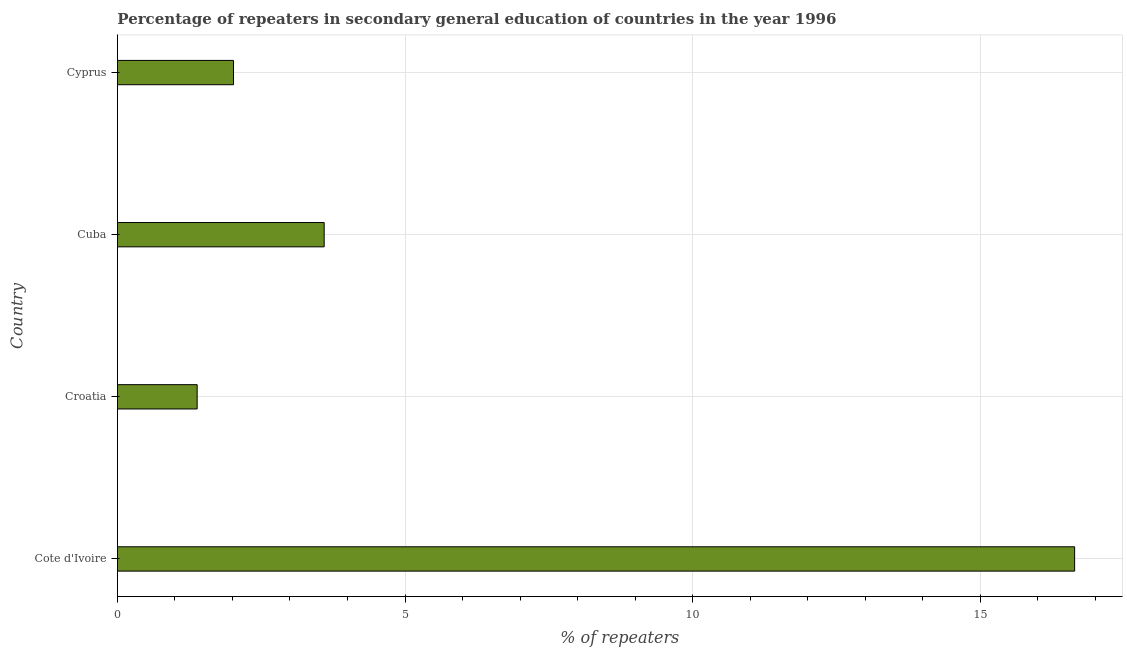What is the title of the graph?
Offer a terse response. Percentage of repeaters in secondary general education of countries in the year 1996. What is the label or title of the X-axis?
Ensure brevity in your answer.  % of repeaters. What is the label or title of the Y-axis?
Offer a terse response. Country. What is the percentage of repeaters in Croatia?
Give a very brief answer. 1.39. Across all countries, what is the maximum percentage of repeaters?
Offer a terse response. 16.64. Across all countries, what is the minimum percentage of repeaters?
Provide a succinct answer. 1.39. In which country was the percentage of repeaters maximum?
Your answer should be compact. Cote d'Ivoire. In which country was the percentage of repeaters minimum?
Make the answer very short. Croatia. What is the sum of the percentage of repeaters?
Your answer should be very brief. 23.64. What is the difference between the percentage of repeaters in Croatia and Cyprus?
Ensure brevity in your answer.  -0.63. What is the average percentage of repeaters per country?
Make the answer very short. 5.91. What is the median percentage of repeaters?
Offer a very short reply. 2.81. In how many countries, is the percentage of repeaters greater than 1 %?
Keep it short and to the point. 4. What is the ratio of the percentage of repeaters in Cote d'Ivoire to that in Cyprus?
Keep it short and to the point. 8.24. Is the percentage of repeaters in Cote d'Ivoire less than that in Cuba?
Offer a very short reply. No. What is the difference between the highest and the second highest percentage of repeaters?
Make the answer very short. 13.05. What is the difference between the highest and the lowest percentage of repeaters?
Give a very brief answer. 15.26. In how many countries, is the percentage of repeaters greater than the average percentage of repeaters taken over all countries?
Provide a succinct answer. 1. How many bars are there?
Your response must be concise. 4. Are all the bars in the graph horizontal?
Provide a short and direct response. Yes. How many countries are there in the graph?
Offer a very short reply. 4. Are the values on the major ticks of X-axis written in scientific E-notation?
Your answer should be very brief. No. What is the % of repeaters in Cote d'Ivoire?
Your response must be concise. 16.64. What is the % of repeaters of Croatia?
Keep it short and to the point. 1.39. What is the % of repeaters in Cuba?
Provide a short and direct response. 3.59. What is the % of repeaters in Cyprus?
Provide a short and direct response. 2.02. What is the difference between the % of repeaters in Cote d'Ivoire and Croatia?
Your answer should be compact. 15.26. What is the difference between the % of repeaters in Cote d'Ivoire and Cuba?
Keep it short and to the point. 13.05. What is the difference between the % of repeaters in Cote d'Ivoire and Cyprus?
Provide a short and direct response. 14.62. What is the difference between the % of repeaters in Croatia and Cuba?
Provide a short and direct response. -2.21. What is the difference between the % of repeaters in Croatia and Cyprus?
Your answer should be very brief. -0.63. What is the difference between the % of repeaters in Cuba and Cyprus?
Your answer should be compact. 1.58. What is the ratio of the % of repeaters in Cote d'Ivoire to that in Croatia?
Offer a very short reply. 12. What is the ratio of the % of repeaters in Cote d'Ivoire to that in Cuba?
Provide a succinct answer. 4.63. What is the ratio of the % of repeaters in Cote d'Ivoire to that in Cyprus?
Provide a short and direct response. 8.24. What is the ratio of the % of repeaters in Croatia to that in Cuba?
Provide a short and direct response. 0.39. What is the ratio of the % of repeaters in Croatia to that in Cyprus?
Offer a very short reply. 0.69. What is the ratio of the % of repeaters in Cuba to that in Cyprus?
Give a very brief answer. 1.78. 